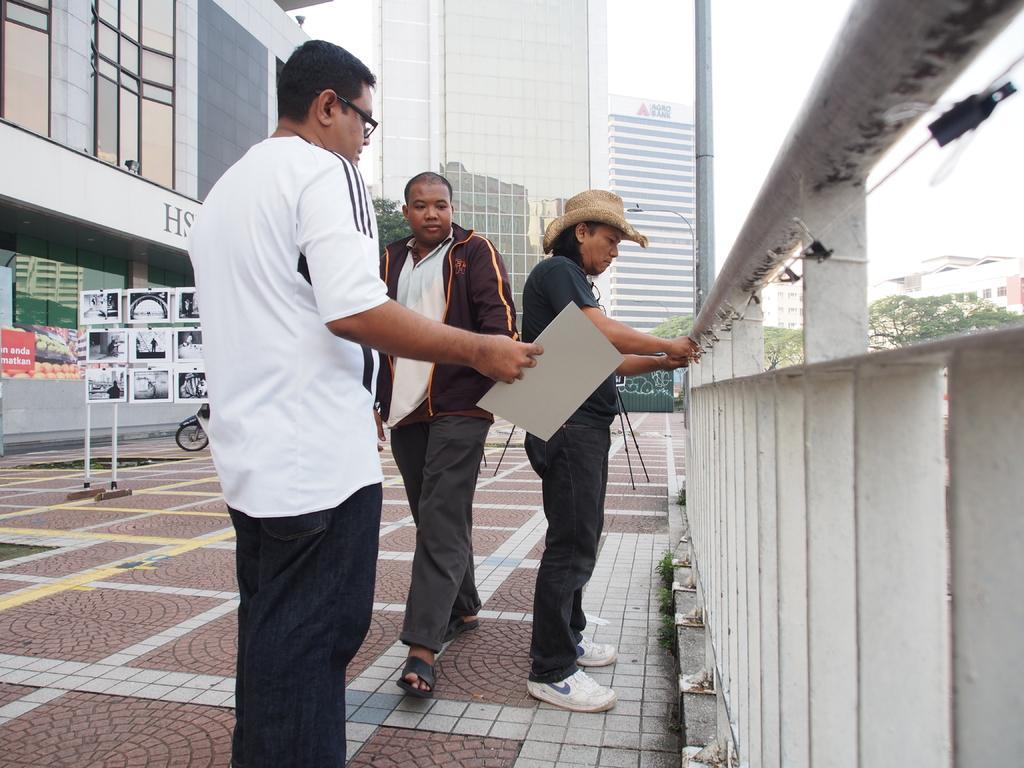Can you describe this image briefly? In this picture I can see the three men in the middle, there is a railing on the right side. On the left side there are boards, in the background I can see the buildings and the trees. 